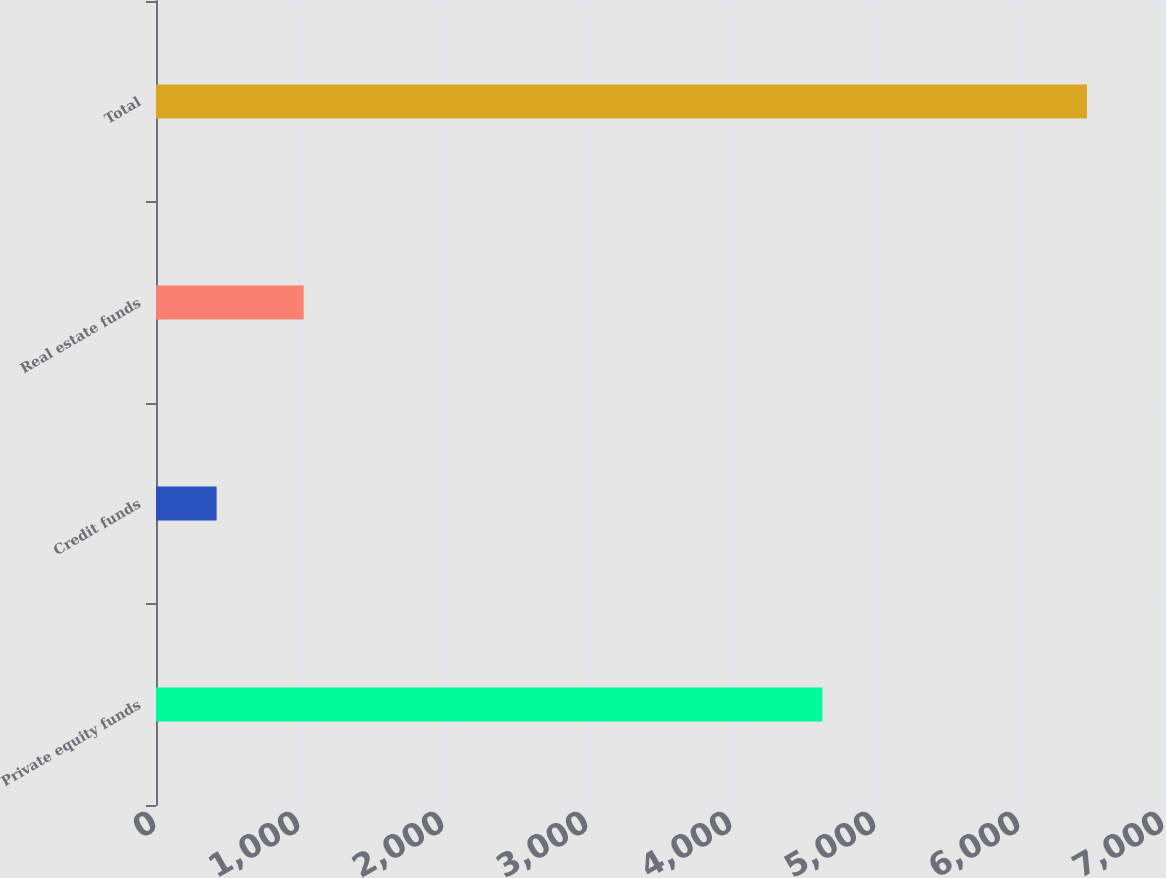Convert chart to OTSL. <chart><loc_0><loc_0><loc_500><loc_500><bar_chart><fcel>Private equity funds<fcel>Credit funds<fcel>Real estate funds<fcel>Total<nl><fcel>4628<fcel>421<fcel>1025.4<fcel>6465<nl></chart> 